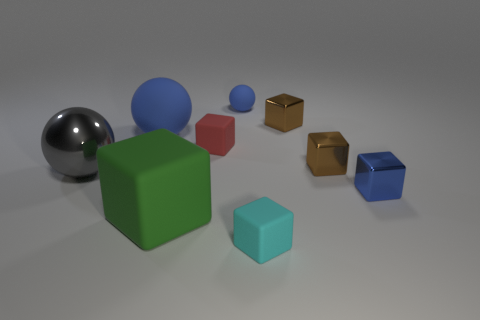Can you speculate on the materials these objects are made of based on their appearance? The reflective sphere suggests a polished metal, while the cubes and other solids might represent materials ranging from matte plastic to potentially wooden surfaces, discernible by their varying textures and light diffuse. 